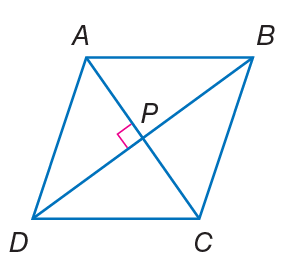Answer the mathemtical geometry problem and directly provide the correct option letter.
Question: Quadrilateral A B C D is a rhombus. If A B = 14, find B C.
Choices: A: 14 B: 18 C: 20 D: 28 A 